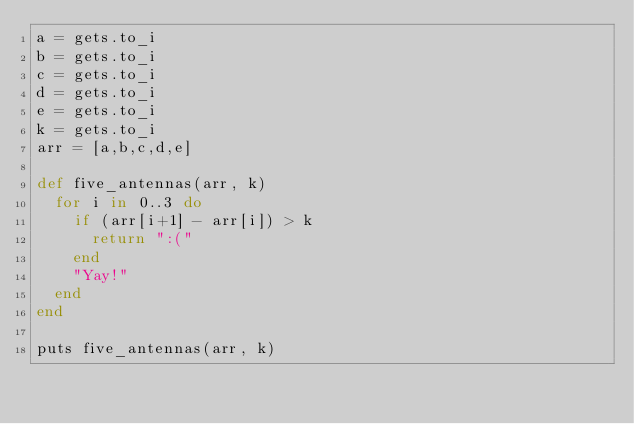<code> <loc_0><loc_0><loc_500><loc_500><_Ruby_>a = gets.to_i
b = gets.to_i
c = gets.to_i
d = gets.to_i
e = gets.to_i
k = gets.to_i
arr = [a,b,c,d,e]

def five_antennas(arr, k)
  for i in 0..3 do
    if (arr[i+1] - arr[i]) > k
      return ":("
    end
    "Yay!"
  end
end

puts five_antennas(arr, k)
</code> 